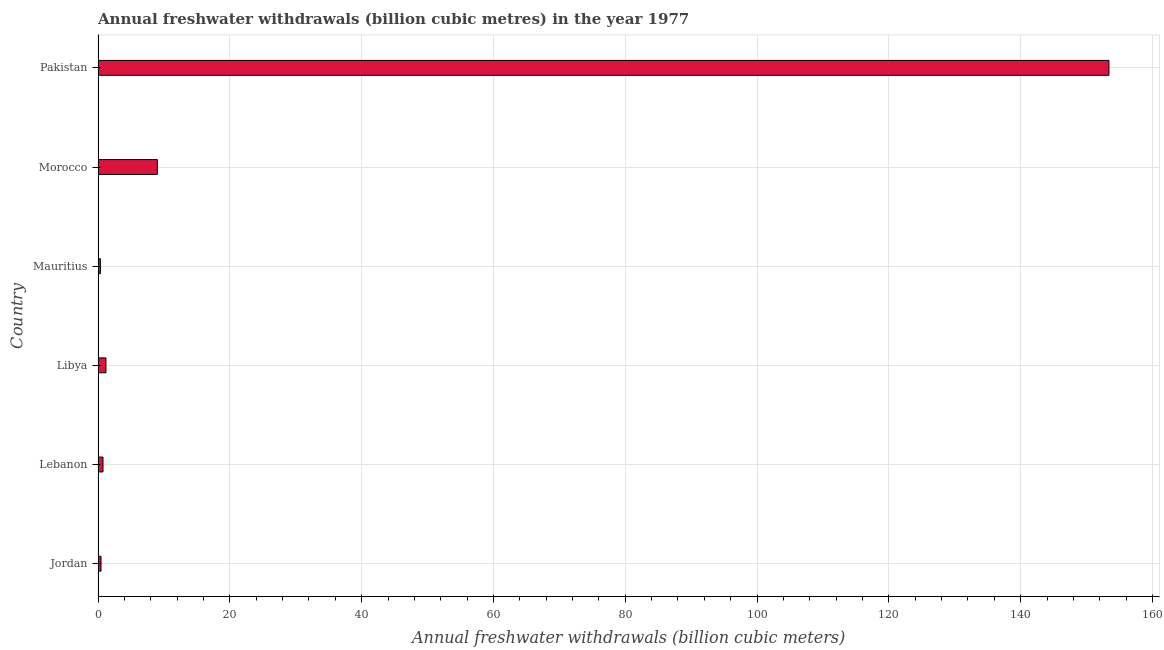Does the graph contain any zero values?
Offer a very short reply. No. Does the graph contain grids?
Ensure brevity in your answer.  Yes. What is the title of the graph?
Offer a terse response. Annual freshwater withdrawals (billion cubic metres) in the year 1977. What is the label or title of the X-axis?
Your answer should be compact. Annual freshwater withdrawals (billion cubic meters). What is the label or title of the Y-axis?
Provide a short and direct response. Country. What is the annual freshwater withdrawals in Lebanon?
Make the answer very short. 0.75. Across all countries, what is the maximum annual freshwater withdrawals?
Ensure brevity in your answer.  153.4. Across all countries, what is the minimum annual freshwater withdrawals?
Give a very brief answer. 0.36. In which country was the annual freshwater withdrawals minimum?
Provide a short and direct response. Mauritius. What is the sum of the annual freshwater withdrawals?
Your answer should be compact. 165.16. What is the difference between the annual freshwater withdrawals in Mauritius and Morocco?
Your response must be concise. -8.64. What is the average annual freshwater withdrawals per country?
Offer a very short reply. 27.53. What is the median annual freshwater withdrawals?
Offer a very short reply. 0.98. What is the ratio of the annual freshwater withdrawals in Jordan to that in Libya?
Your response must be concise. 0.38. Is the annual freshwater withdrawals in Libya less than that in Pakistan?
Provide a short and direct response. Yes. What is the difference between the highest and the second highest annual freshwater withdrawals?
Make the answer very short. 144.4. What is the difference between the highest and the lowest annual freshwater withdrawals?
Your response must be concise. 153.04. Are all the bars in the graph horizontal?
Offer a very short reply. Yes. Are the values on the major ticks of X-axis written in scientific E-notation?
Give a very brief answer. No. What is the Annual freshwater withdrawals (billion cubic meters) in Jordan?
Offer a very short reply. 0.45. What is the Annual freshwater withdrawals (billion cubic meters) in Lebanon?
Keep it short and to the point. 0.75. What is the Annual freshwater withdrawals (billion cubic meters) in Libya?
Your response must be concise. 1.2. What is the Annual freshwater withdrawals (billion cubic meters) of Mauritius?
Provide a succinct answer. 0.36. What is the Annual freshwater withdrawals (billion cubic meters) of Pakistan?
Your answer should be compact. 153.4. What is the difference between the Annual freshwater withdrawals (billion cubic meters) in Jordan and Libya?
Offer a very short reply. -0.75. What is the difference between the Annual freshwater withdrawals (billion cubic meters) in Jordan and Mauritius?
Your answer should be very brief. 0.09. What is the difference between the Annual freshwater withdrawals (billion cubic meters) in Jordan and Morocco?
Give a very brief answer. -8.55. What is the difference between the Annual freshwater withdrawals (billion cubic meters) in Jordan and Pakistan?
Ensure brevity in your answer.  -152.95. What is the difference between the Annual freshwater withdrawals (billion cubic meters) in Lebanon and Libya?
Provide a succinct answer. -0.45. What is the difference between the Annual freshwater withdrawals (billion cubic meters) in Lebanon and Mauritius?
Your answer should be compact. 0.39. What is the difference between the Annual freshwater withdrawals (billion cubic meters) in Lebanon and Morocco?
Your answer should be very brief. -8.25. What is the difference between the Annual freshwater withdrawals (billion cubic meters) in Lebanon and Pakistan?
Offer a terse response. -152.65. What is the difference between the Annual freshwater withdrawals (billion cubic meters) in Libya and Mauritius?
Keep it short and to the point. 0.84. What is the difference between the Annual freshwater withdrawals (billion cubic meters) in Libya and Morocco?
Your answer should be compact. -7.8. What is the difference between the Annual freshwater withdrawals (billion cubic meters) in Libya and Pakistan?
Keep it short and to the point. -152.2. What is the difference between the Annual freshwater withdrawals (billion cubic meters) in Mauritius and Morocco?
Offer a very short reply. -8.64. What is the difference between the Annual freshwater withdrawals (billion cubic meters) in Mauritius and Pakistan?
Ensure brevity in your answer.  -153.04. What is the difference between the Annual freshwater withdrawals (billion cubic meters) in Morocco and Pakistan?
Ensure brevity in your answer.  -144.4. What is the ratio of the Annual freshwater withdrawals (billion cubic meters) in Jordan to that in Lebanon?
Make the answer very short. 0.6. What is the ratio of the Annual freshwater withdrawals (billion cubic meters) in Jordan to that in Libya?
Provide a short and direct response. 0.38. What is the ratio of the Annual freshwater withdrawals (billion cubic meters) in Jordan to that in Mauritius?
Give a very brief answer. 1.25. What is the ratio of the Annual freshwater withdrawals (billion cubic meters) in Jordan to that in Pakistan?
Offer a very short reply. 0. What is the ratio of the Annual freshwater withdrawals (billion cubic meters) in Lebanon to that in Libya?
Make the answer very short. 0.63. What is the ratio of the Annual freshwater withdrawals (billion cubic meters) in Lebanon to that in Mauritius?
Provide a short and direct response. 2.09. What is the ratio of the Annual freshwater withdrawals (billion cubic meters) in Lebanon to that in Morocco?
Your answer should be compact. 0.08. What is the ratio of the Annual freshwater withdrawals (billion cubic meters) in Lebanon to that in Pakistan?
Give a very brief answer. 0.01. What is the ratio of the Annual freshwater withdrawals (billion cubic meters) in Libya to that in Mauritius?
Keep it short and to the point. 3.33. What is the ratio of the Annual freshwater withdrawals (billion cubic meters) in Libya to that in Morocco?
Ensure brevity in your answer.  0.13. What is the ratio of the Annual freshwater withdrawals (billion cubic meters) in Libya to that in Pakistan?
Ensure brevity in your answer.  0.01. What is the ratio of the Annual freshwater withdrawals (billion cubic meters) in Mauritius to that in Pakistan?
Ensure brevity in your answer.  0. What is the ratio of the Annual freshwater withdrawals (billion cubic meters) in Morocco to that in Pakistan?
Your response must be concise. 0.06. 